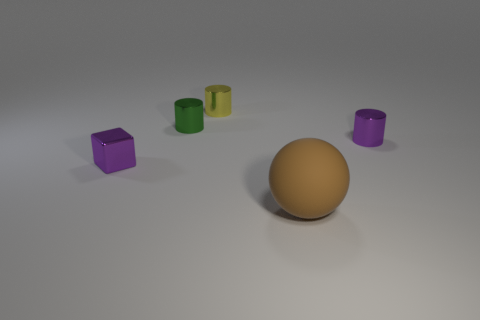There is a shiny object that is in front of the purple shiny thing that is right of the big sphere; what color is it?
Provide a short and direct response. Purple. How many other objects are the same material as the yellow object?
Provide a succinct answer. 3. What number of other things are there of the same color as the big thing?
Your answer should be very brief. 0. There is a tiny purple thing behind the purple metallic thing to the left of the yellow shiny object; what is its material?
Provide a succinct answer. Metal. Are any small yellow cylinders visible?
Offer a very short reply. Yes. How big is the purple thing behind the metallic object in front of the purple shiny cylinder?
Offer a terse response. Small. Is the number of brown rubber balls that are to the left of the small green cylinder greater than the number of small blocks that are behind the yellow cylinder?
Your answer should be very brief. No. What number of blocks are green objects or small brown metal things?
Your answer should be very brief. 0. Is there anything else that is the same size as the rubber object?
Your response must be concise. No. Is the shape of the purple metal object that is left of the green thing the same as  the yellow metallic object?
Ensure brevity in your answer.  No. 